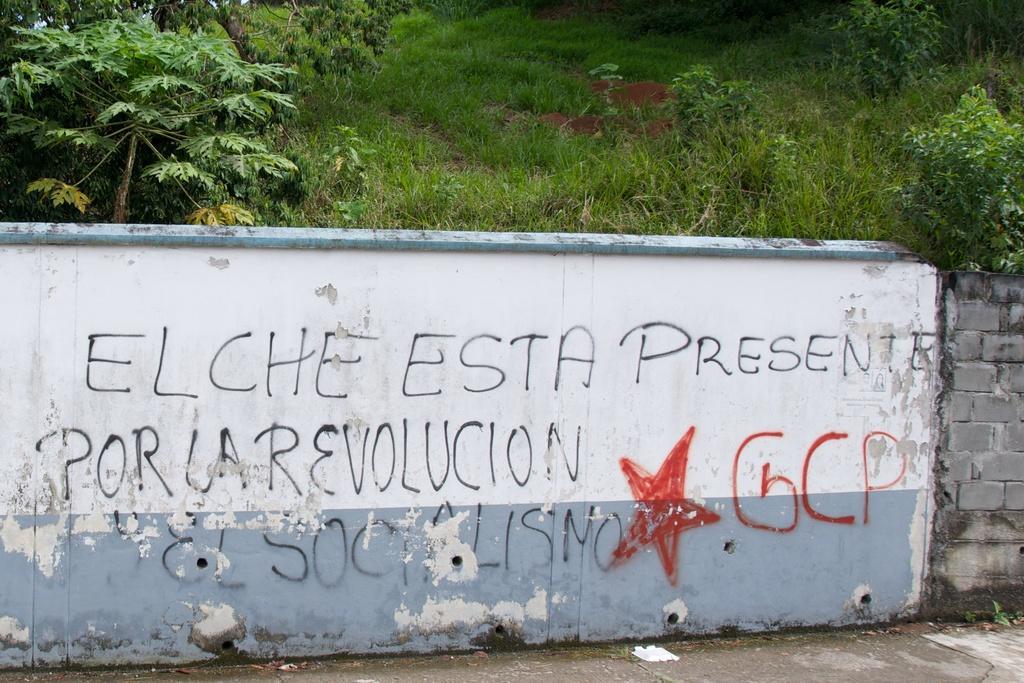In one or two sentences, can you explain what this image depicts? In this image I can see a wall which is in white and blue color and something is written on it. Back I can see trees and green grass. 